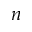Convert formula to latex. <formula><loc_0><loc_0><loc_500><loc_500>n</formula> 